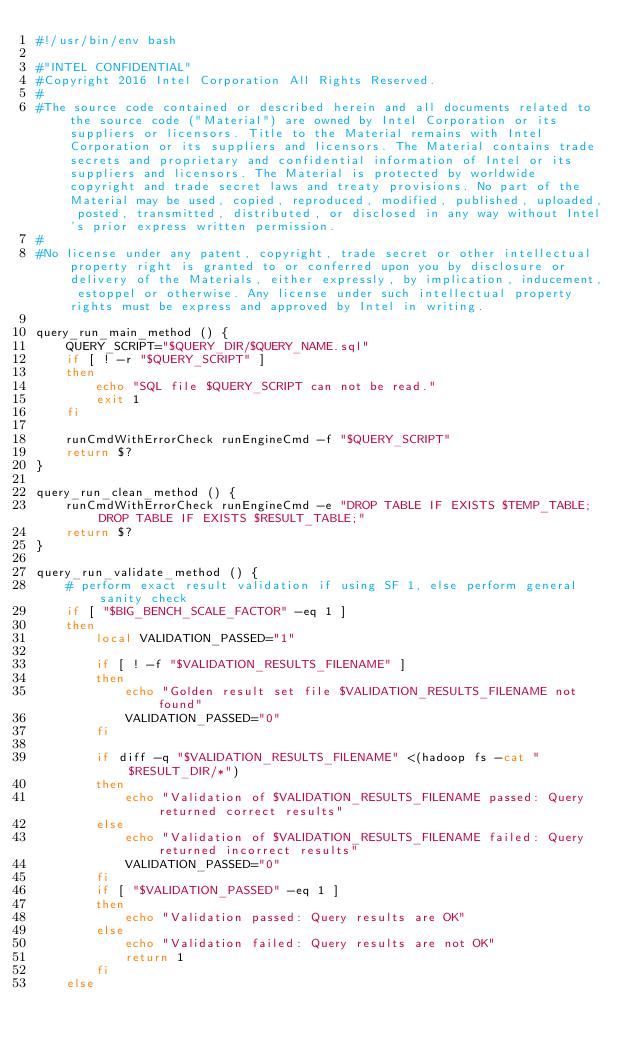Convert code to text. <code><loc_0><loc_0><loc_500><loc_500><_Bash_>#!/usr/bin/env bash

#"INTEL CONFIDENTIAL"
#Copyright 2016 Intel Corporation All Rights Reserved. 
#
#The source code contained or described herein and all documents related to the source code ("Material") are owned by Intel Corporation or its suppliers or licensors. Title to the Material remains with Intel Corporation or its suppliers and licensors. The Material contains trade secrets and proprietary and confidential information of Intel or its suppliers and licensors. The Material is protected by worldwide copyright and trade secret laws and treaty provisions. No part of the Material may be used, copied, reproduced, modified, published, uploaded, posted, transmitted, distributed, or disclosed in any way without Intel's prior express written permission.
#
#No license under any patent, copyright, trade secret or other intellectual property right is granted to or conferred upon you by disclosure or delivery of the Materials, either expressly, by implication, inducement, estoppel or otherwise. Any license under such intellectual property rights must be express and approved by Intel in writing.

query_run_main_method () {
	QUERY_SCRIPT="$QUERY_DIR/$QUERY_NAME.sql"
	if [ ! -r "$QUERY_SCRIPT" ]
	then
		echo "SQL file $QUERY_SCRIPT can not be read."
		exit 1
	fi

	runCmdWithErrorCheck runEngineCmd -f "$QUERY_SCRIPT"
	return $?
}

query_run_clean_method () {
	runCmdWithErrorCheck runEngineCmd -e "DROP TABLE IF EXISTS $TEMP_TABLE; DROP TABLE IF EXISTS $RESULT_TABLE;"
	return $?
}

query_run_validate_method () {
	# perform exact result validation if using SF 1, else perform general sanity check
	if [ "$BIG_BENCH_SCALE_FACTOR" -eq 1 ]
	then
		local VALIDATION_PASSED="1"

		if [ ! -f "$VALIDATION_RESULTS_FILENAME" ]
		then
			echo "Golden result set file $VALIDATION_RESULTS_FILENAME not found"
			VALIDATION_PASSED="0"
		fi

		if diff -q "$VALIDATION_RESULTS_FILENAME" <(hadoop fs -cat "$RESULT_DIR/*")
		then
			echo "Validation of $VALIDATION_RESULTS_FILENAME passed: Query returned correct results"
		else
			echo "Validation of $VALIDATION_RESULTS_FILENAME failed: Query returned incorrect results"
			VALIDATION_PASSED="0"
		fi
		if [ "$VALIDATION_PASSED" -eq 1 ]
		then
			echo "Validation passed: Query results are OK"
		else
			echo "Validation failed: Query results are not OK"
			return 1
		fi
	else</code> 